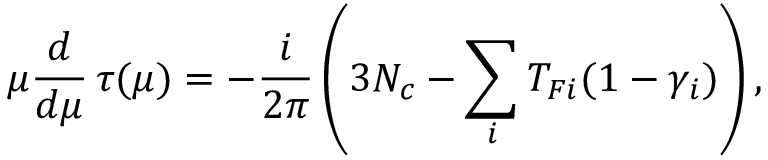Convert formula to latex. <formula><loc_0><loc_0><loc_500><loc_500>\mu { \frac { d } { d \mu } } \, \tau ( \mu ) = - { \frac { i } { 2 \pi } } \left ( 3 N _ { c } - \sum _ { i } T _ { F i } ( 1 - \gamma _ { i } ) \right ) ,</formula> 